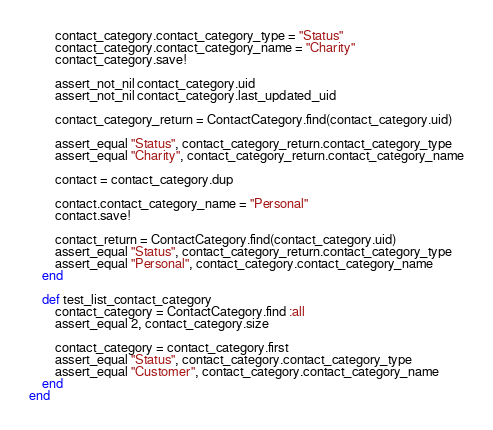Convert code to text. <code><loc_0><loc_0><loc_500><loc_500><_Ruby_>		contact_category.contact_category_type = "Status"
		contact_category.contact_category_name = "Charity"
		contact_category.save!

		assert_not_nil contact_category.uid
		assert_not_nil contact_category.last_updated_uid

		contact_category_return = ContactCategory.find(contact_category.uid)

		assert_equal "Status", contact_category_return.contact_category_type
		assert_equal "Charity", contact_category_return.contact_category_name

		contact = contact_category.dup

		contact.contact_category_name = "Personal"
		contact.save!

		contact_return = ContactCategory.find(contact_category.uid)
		assert_equal "Status", contact_category_return.contact_category_type
		assert_equal "Personal", contact_category.contact_category_name
	end

	def test_list_contact_category
		contact_category = ContactCategory.find :all
		assert_equal 2, contact_category.size

		contact_category = contact_category.first
		assert_equal "Status", contact_category.contact_category_type
		assert_equal "Customer", contact_category.contact_category_name
	end
end
</code> 